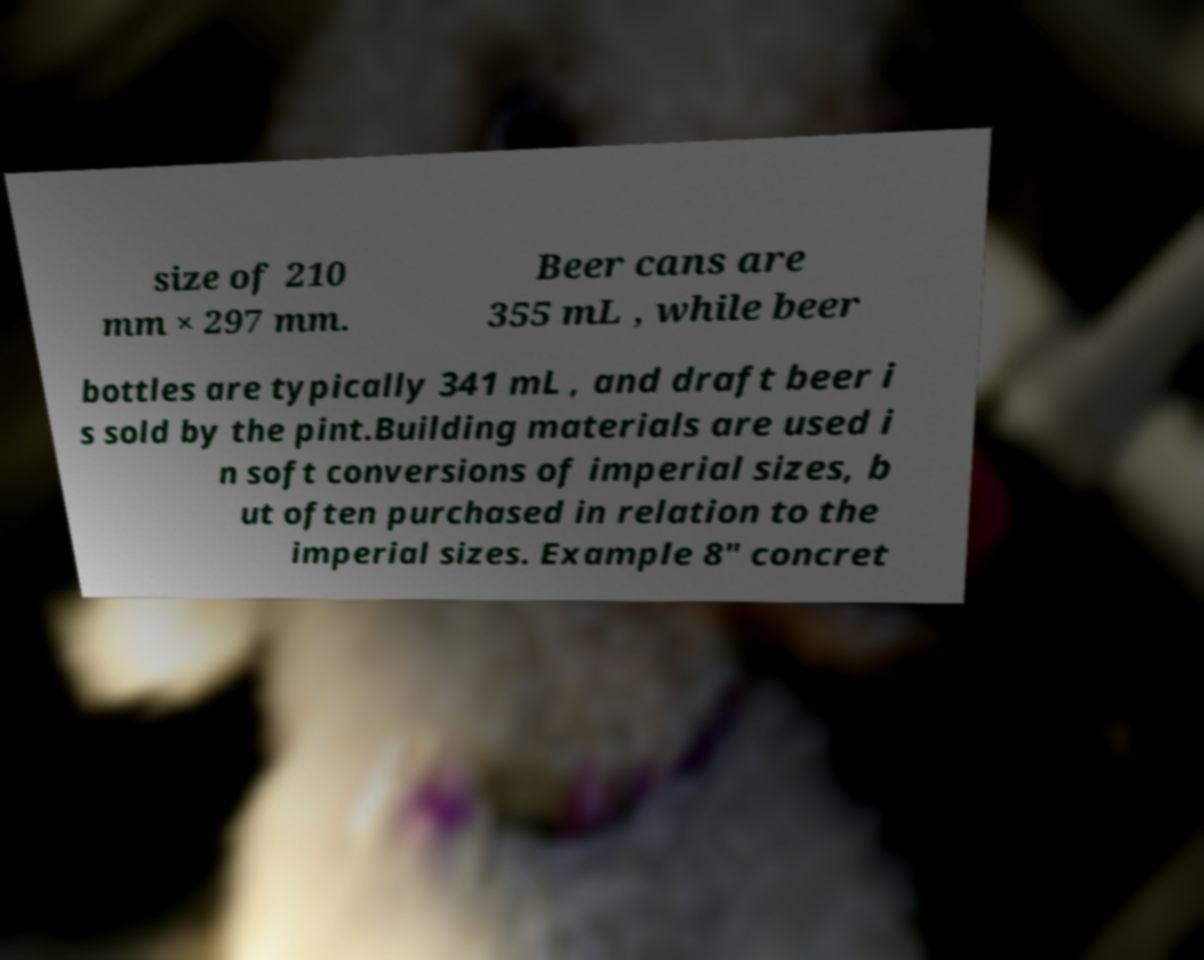Could you extract and type out the text from this image? size of 210 mm × 297 mm. Beer cans are 355 mL , while beer bottles are typically 341 mL , and draft beer i s sold by the pint.Building materials are used i n soft conversions of imperial sizes, b ut often purchased in relation to the imperial sizes. Example 8" concret 